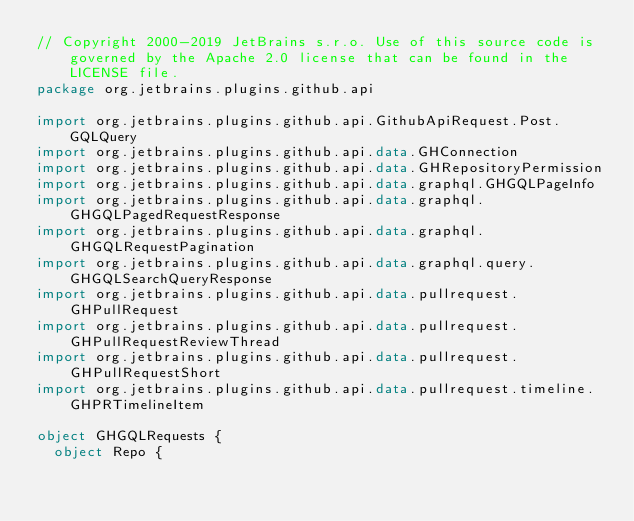<code> <loc_0><loc_0><loc_500><loc_500><_Kotlin_>// Copyright 2000-2019 JetBrains s.r.o. Use of this source code is governed by the Apache 2.0 license that can be found in the LICENSE file.
package org.jetbrains.plugins.github.api

import org.jetbrains.plugins.github.api.GithubApiRequest.Post.GQLQuery
import org.jetbrains.plugins.github.api.data.GHConnection
import org.jetbrains.plugins.github.api.data.GHRepositoryPermission
import org.jetbrains.plugins.github.api.data.graphql.GHGQLPageInfo
import org.jetbrains.plugins.github.api.data.graphql.GHGQLPagedRequestResponse
import org.jetbrains.plugins.github.api.data.graphql.GHGQLRequestPagination
import org.jetbrains.plugins.github.api.data.graphql.query.GHGQLSearchQueryResponse
import org.jetbrains.plugins.github.api.data.pullrequest.GHPullRequest
import org.jetbrains.plugins.github.api.data.pullrequest.GHPullRequestReviewThread
import org.jetbrains.plugins.github.api.data.pullrequest.GHPullRequestShort
import org.jetbrains.plugins.github.api.data.pullrequest.timeline.GHPRTimelineItem

object GHGQLRequests {
  object Repo {</code> 